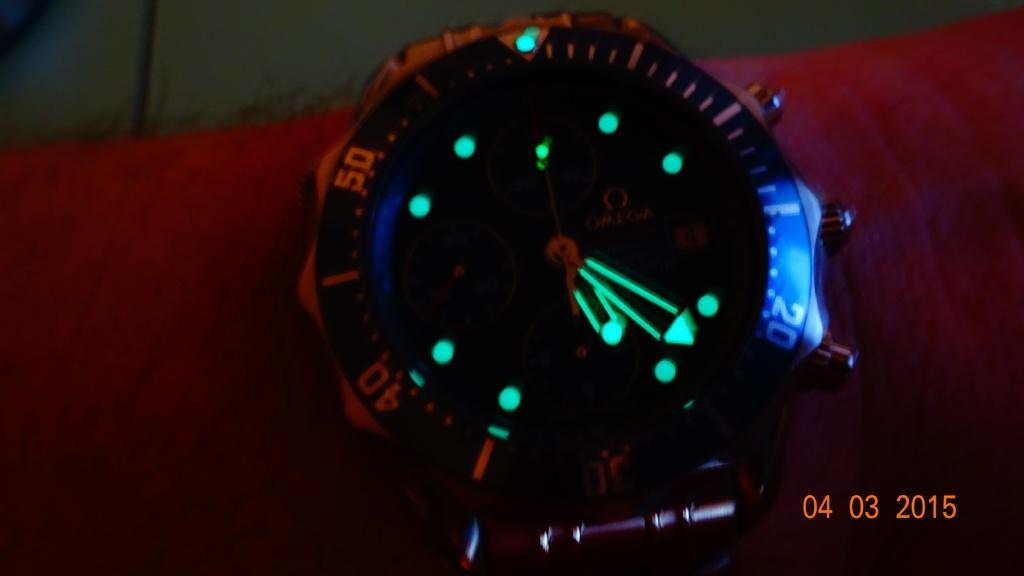Provide a one-sentence caption for the provided image. Even thought is dark, the number 20 stands out on the dial of the watch. 